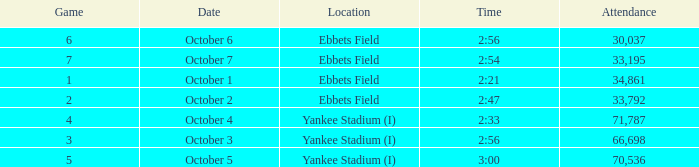Date of October 1 has what average game? 1.0. 